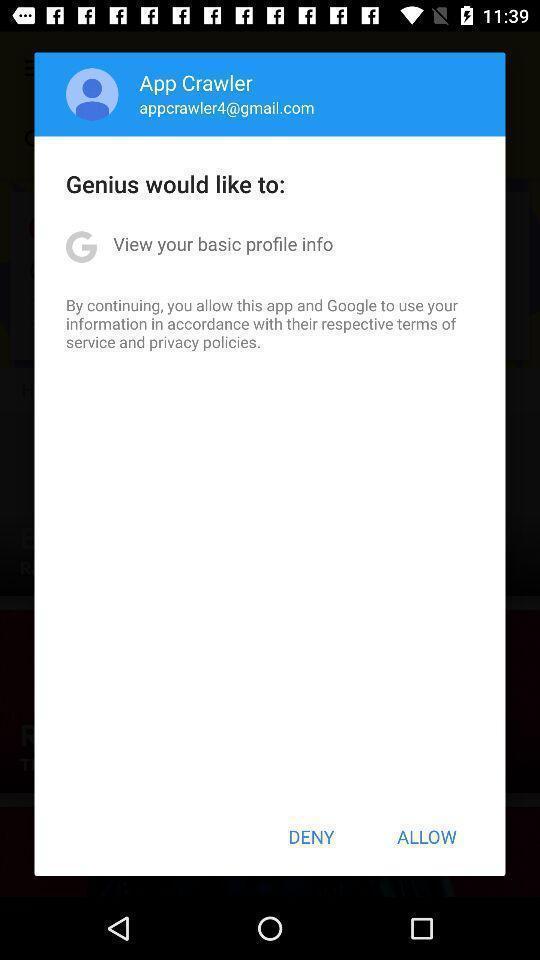Summarize the main components in this picture. Pop-up showing deny or allow option. 